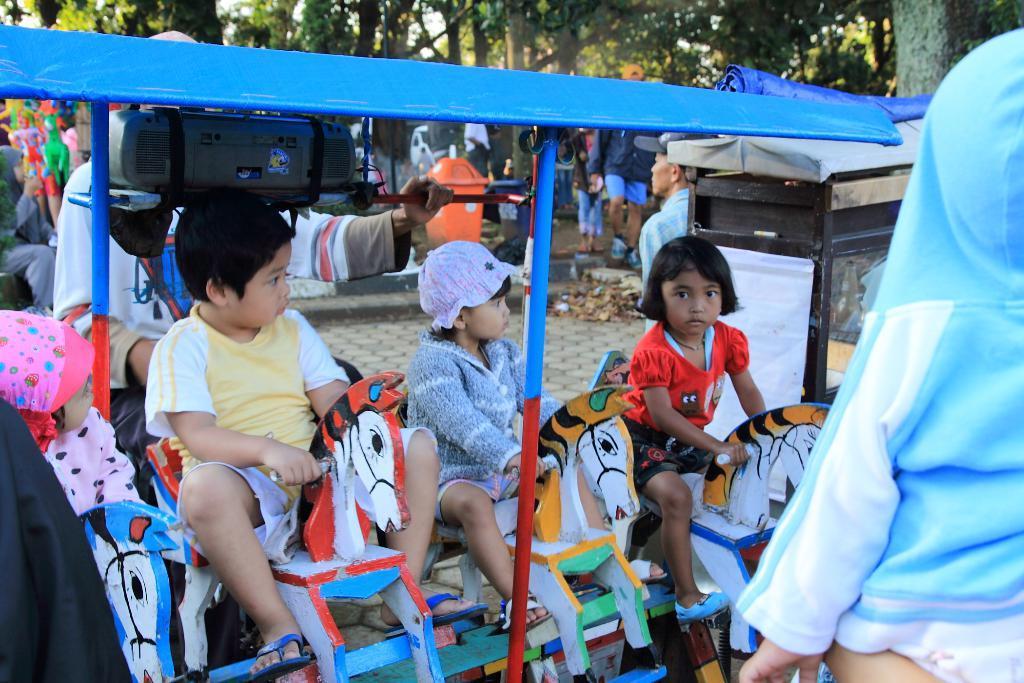Please provide a concise description of this image. In this image, there are a few people. Among them, some people are sitting on horse cradles. We can see the shed and a device. We can see the ground with some objects. There are a few trees. We can see an object with a glass and a poster attached to it. 